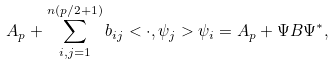Convert formula to latex. <formula><loc_0><loc_0><loc_500><loc_500>A _ { p } + \sum _ { i , j = 1 } ^ { n ( p / 2 + 1 ) } { b } _ { i j } < \cdot , \psi _ { j } > \psi _ { i } = A _ { p } + \Psi B \Psi ^ { * } ,</formula> 